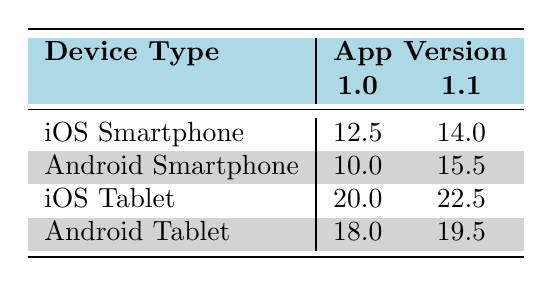What is the average session duration for iOS Tablet with app version 1.1? From the table, for iOS Tablet with app version 1.1, the average session duration is provided directly as 22.5 minutes.
Answer: 22.5 What is the average session duration for Android Smartphone for app version 1.0? The table indicates that for Android Smartphone with app version 1.0, the average session duration is 10.0 minutes.
Answer: 10.0 Which device type has the longest average session duration for app version 1.0? Looking at app version 1.0, the average session durations are: iOS Smartphone 12.5, Android Smartphone 10.0, iOS Tablet 20.0, and Android Tablet 18.0. The longest is 20.0 for iOS Tablet.
Answer: iOS Tablet Is the average session duration longer for app version 1.1 compared to 1.0 for Android Tablet? For Android Tablet app version 1.0, the duration is 18.0 minutes, while for version 1.1 it is 19.5 minutes. Since 19.5 is greater than 18.0, the session duration is indeed longer for app version 1.1.
Answer: Yes What is the percentage increase in average session duration for iOS Smartphone from version 1.0 to 1.1? For iOS Smartphone, version 1.0 is 12.5 minutes and version 1.1 is 14.0 minutes. To calculate the percentage increase: (14.0 - 12.5) / 12.5 * 100 = 12.0%.
Answer: 12.0% Which device type showed the highest increase in average session duration when comparing versions 1.0 and 1.1? Calculating the increase for each device: iOS Smartphone: 1.5 (from 12.5 to 14.0), Android Smartphone: 5.5 (from 10.0 to 15.5), iOS Tablet: 2.5 (from 20.0 to 22.5), and Android Tablet: 1.5 (from 18.0 to 19.5). The Android Smartphone has the highest increase of 5.5 minutes.
Answer: Android Smartphone Is the average session duration for iOS Tablet always greater than that of iOS Smartphone? Checking the averages: iOS Tablet app version 1.0 is 20.0 and 1.1 is 22.5; iOS Smartphone app version 1.0 is 12.5 and 1.1 is 14.0. Since both values for iOS Tablet are greater than those for iOS Smartphone, it holds true.
Answer: Yes What is the difference in average session duration between the highest and lowest app versions for Android Tablet? For Android Tablet, the average session duration for version 1.0 is 18.0 and for version 1.1 is 19.5. The difference is 19.5 - 18.0 = 1.5 minutes.
Answer: 1.5 